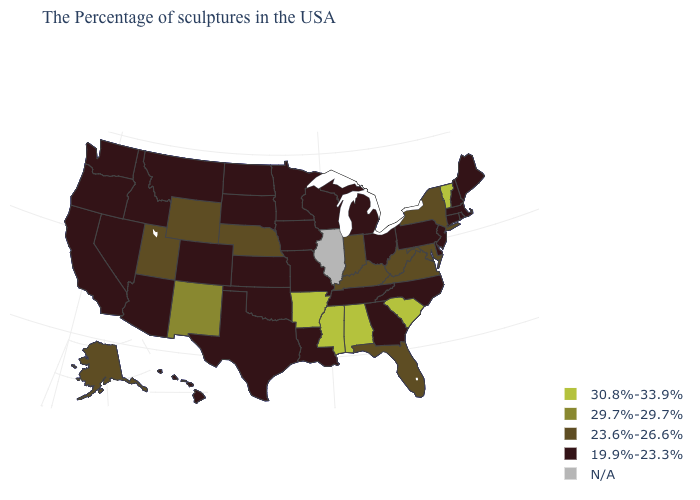What is the value of Virginia?
Give a very brief answer. 23.6%-26.6%. What is the value of Nevada?
Be succinct. 19.9%-23.3%. Name the states that have a value in the range 23.6%-26.6%?
Short answer required. New York, Maryland, Virginia, West Virginia, Florida, Kentucky, Indiana, Nebraska, Wyoming, Utah, Alaska. Which states have the lowest value in the USA?
Write a very short answer. Maine, Massachusetts, Rhode Island, New Hampshire, Connecticut, New Jersey, Delaware, Pennsylvania, North Carolina, Ohio, Georgia, Michigan, Tennessee, Wisconsin, Louisiana, Missouri, Minnesota, Iowa, Kansas, Oklahoma, Texas, South Dakota, North Dakota, Colorado, Montana, Arizona, Idaho, Nevada, California, Washington, Oregon, Hawaii. What is the lowest value in the Northeast?
Keep it brief. 19.9%-23.3%. What is the value of Wisconsin?
Quick response, please. 19.9%-23.3%. Does Maryland have the lowest value in the USA?
Quick response, please. No. Which states have the highest value in the USA?
Be succinct. Vermont, South Carolina, Alabama, Mississippi, Arkansas. What is the value of Virginia?
Short answer required. 23.6%-26.6%. What is the value of South Dakota?
Keep it brief. 19.9%-23.3%. Name the states that have a value in the range N/A?
Short answer required. Illinois. Name the states that have a value in the range 23.6%-26.6%?
Keep it brief. New York, Maryland, Virginia, West Virginia, Florida, Kentucky, Indiana, Nebraska, Wyoming, Utah, Alaska. What is the value of Tennessee?
Quick response, please. 19.9%-23.3%. Does Florida have the highest value in the South?
Write a very short answer. No. 